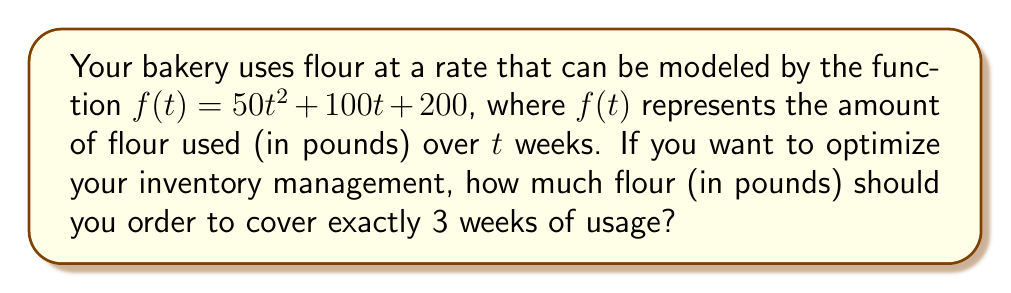Show me your answer to this math problem. To solve this problem, we need to follow these steps:

1) The function $f(t) = 50t^2 + 100t + 200$ represents the cumulative amount of flour used over time.

2) To find the amount used in exactly 3 weeks, we need to calculate $f(3)$:

   $f(3) = 50(3)^2 + 100(3) + 200$

3) Let's break this down:
   - $50(3)^2 = 50(9) = 450$
   - $100(3) = 300$
   - The constant term is 200

4) Now, let's sum these up:

   $f(3) = 450 + 300 + 200 = 950$

5) Therefore, over a 3-week period, the bakery will use 950 pounds of flour.
Answer: 950 pounds 